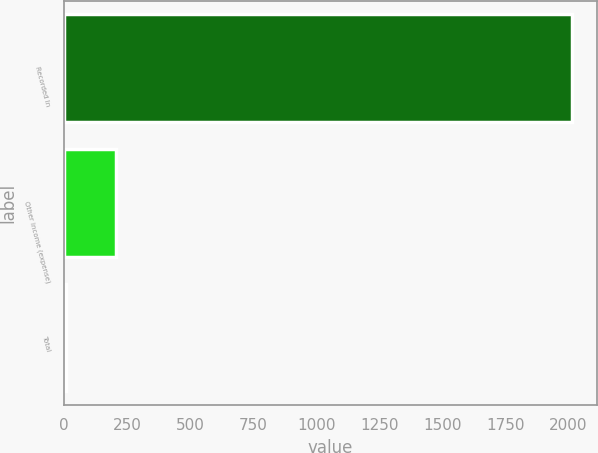<chart> <loc_0><loc_0><loc_500><loc_500><bar_chart><fcel>Recorded In<fcel>Other income (expense)<fcel>Total<nl><fcel>2014<fcel>207.7<fcel>7<nl></chart> 